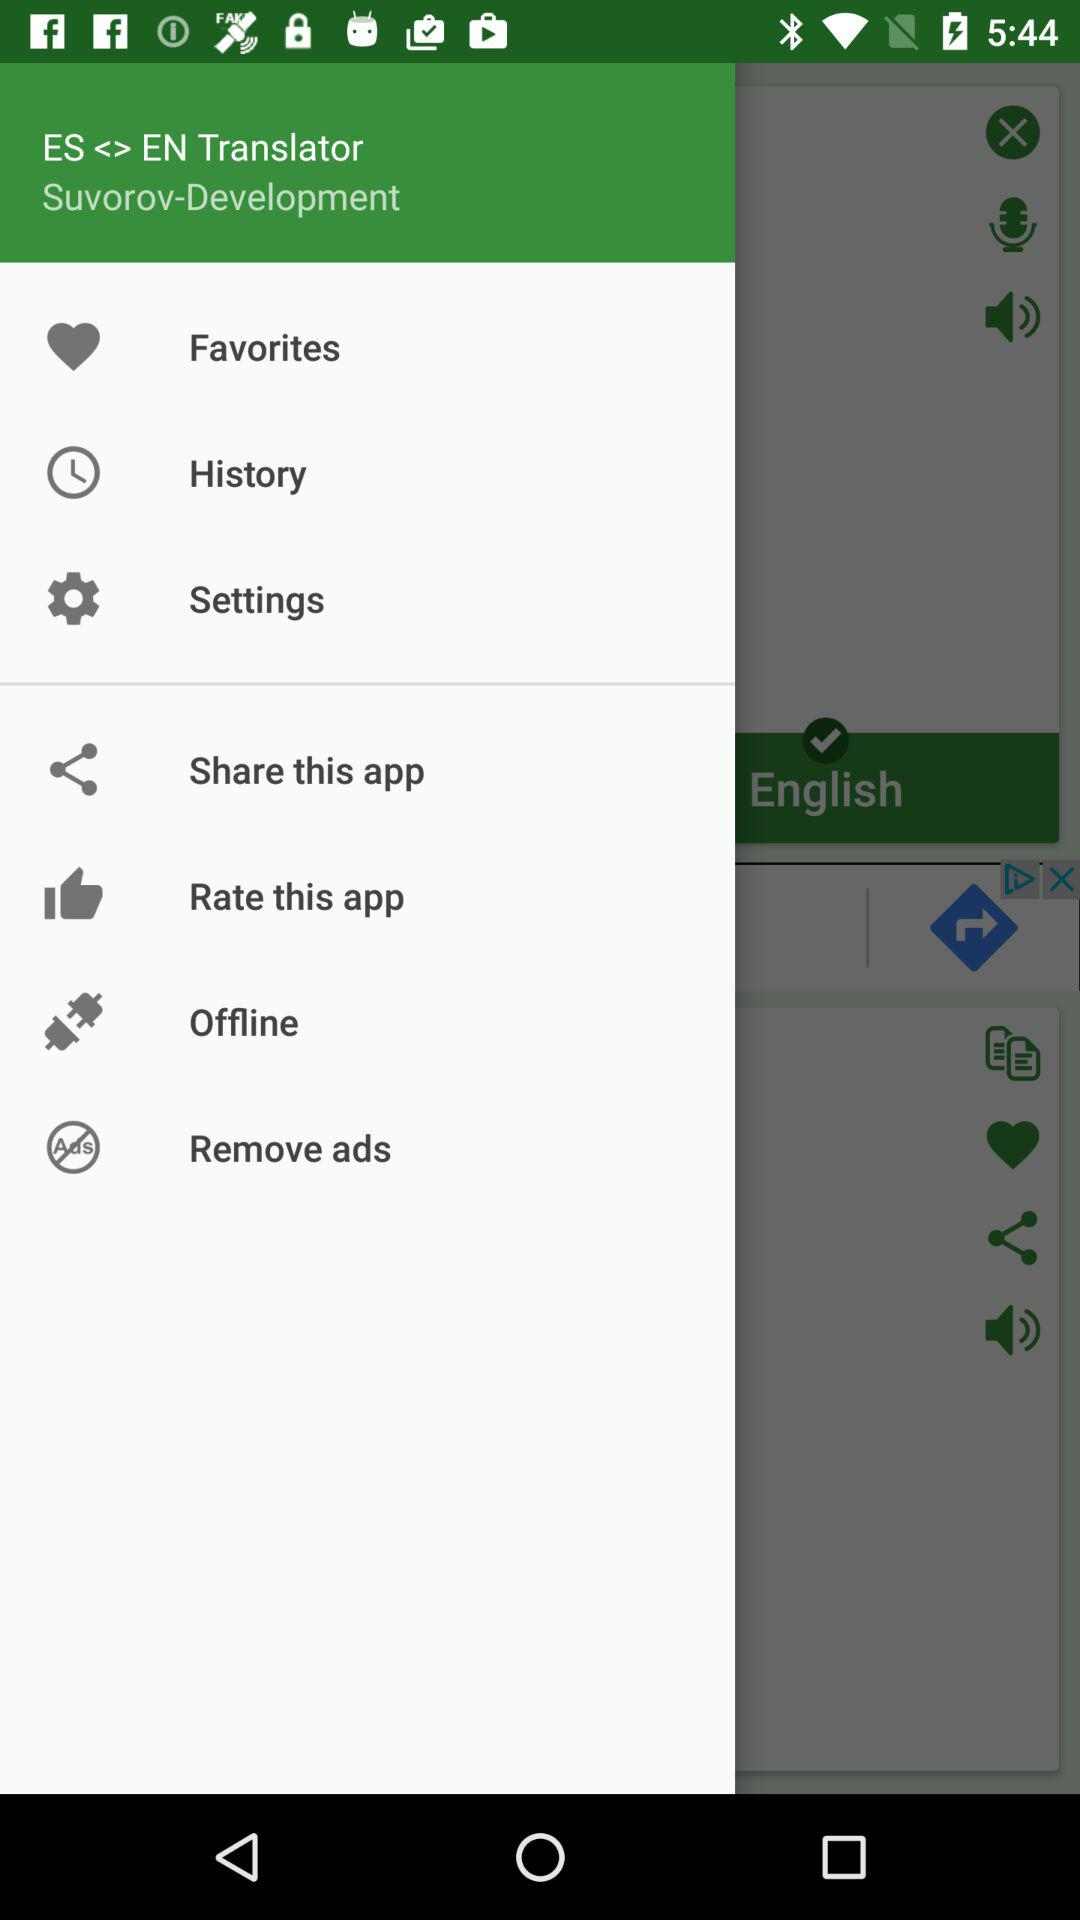Which language has been selected? The selected language is English. 